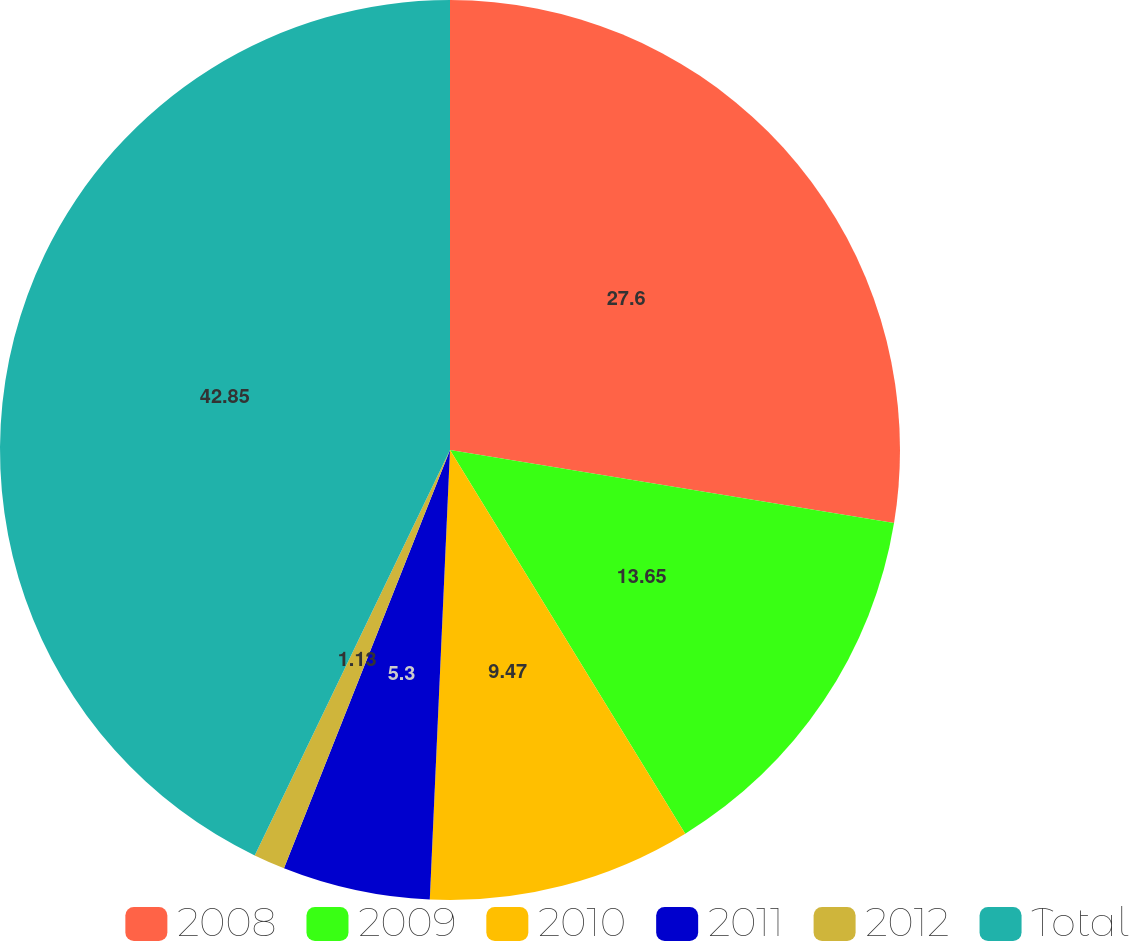Convert chart. <chart><loc_0><loc_0><loc_500><loc_500><pie_chart><fcel>2008<fcel>2009<fcel>2010<fcel>2011<fcel>2012<fcel>Total<nl><fcel>27.6%<fcel>13.65%<fcel>9.47%<fcel>5.3%<fcel>1.13%<fcel>42.86%<nl></chart> 